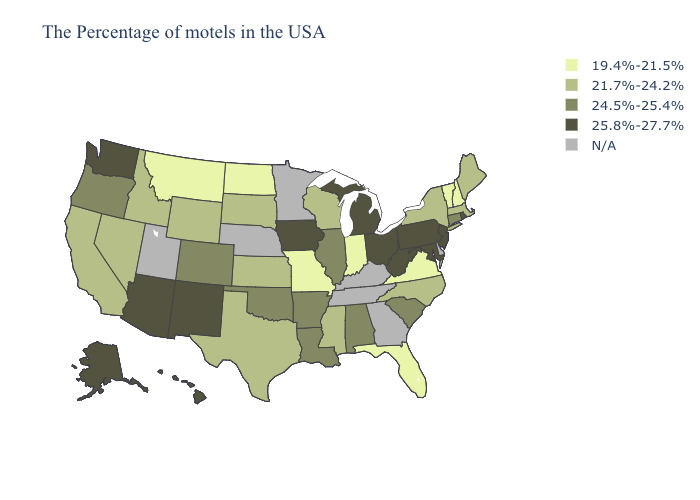Which states have the highest value in the USA?
Be succinct. Rhode Island, New Jersey, Maryland, Pennsylvania, West Virginia, Ohio, Michigan, Iowa, New Mexico, Arizona, Washington, Alaska, Hawaii. Among the states that border Illinois , which have the lowest value?
Concise answer only. Indiana, Missouri. What is the lowest value in the MidWest?
Give a very brief answer. 19.4%-21.5%. What is the value of Pennsylvania?
Quick response, please. 25.8%-27.7%. What is the highest value in states that border Nebraska?
Concise answer only. 25.8%-27.7%. Which states have the highest value in the USA?
Quick response, please. Rhode Island, New Jersey, Maryland, Pennsylvania, West Virginia, Ohio, Michigan, Iowa, New Mexico, Arizona, Washington, Alaska, Hawaii. Which states have the lowest value in the MidWest?
Write a very short answer. Indiana, Missouri, North Dakota. Is the legend a continuous bar?
Give a very brief answer. No. Does Virginia have the lowest value in the South?
Short answer required. Yes. Name the states that have a value in the range 21.7%-24.2%?
Write a very short answer. Maine, Massachusetts, New York, North Carolina, Wisconsin, Mississippi, Kansas, Texas, South Dakota, Wyoming, Idaho, Nevada, California. What is the highest value in the Northeast ?
Keep it brief. 25.8%-27.7%. Does the map have missing data?
Be succinct. Yes. Name the states that have a value in the range 24.5%-25.4%?
Keep it brief. Connecticut, South Carolina, Alabama, Illinois, Louisiana, Arkansas, Oklahoma, Colorado, Oregon. 